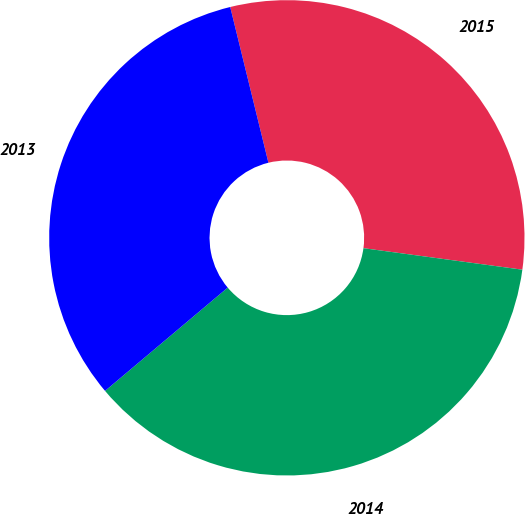Convert chart to OTSL. <chart><loc_0><loc_0><loc_500><loc_500><pie_chart><fcel>2015<fcel>2014<fcel>2013<nl><fcel>30.97%<fcel>36.72%<fcel>32.31%<nl></chart> 